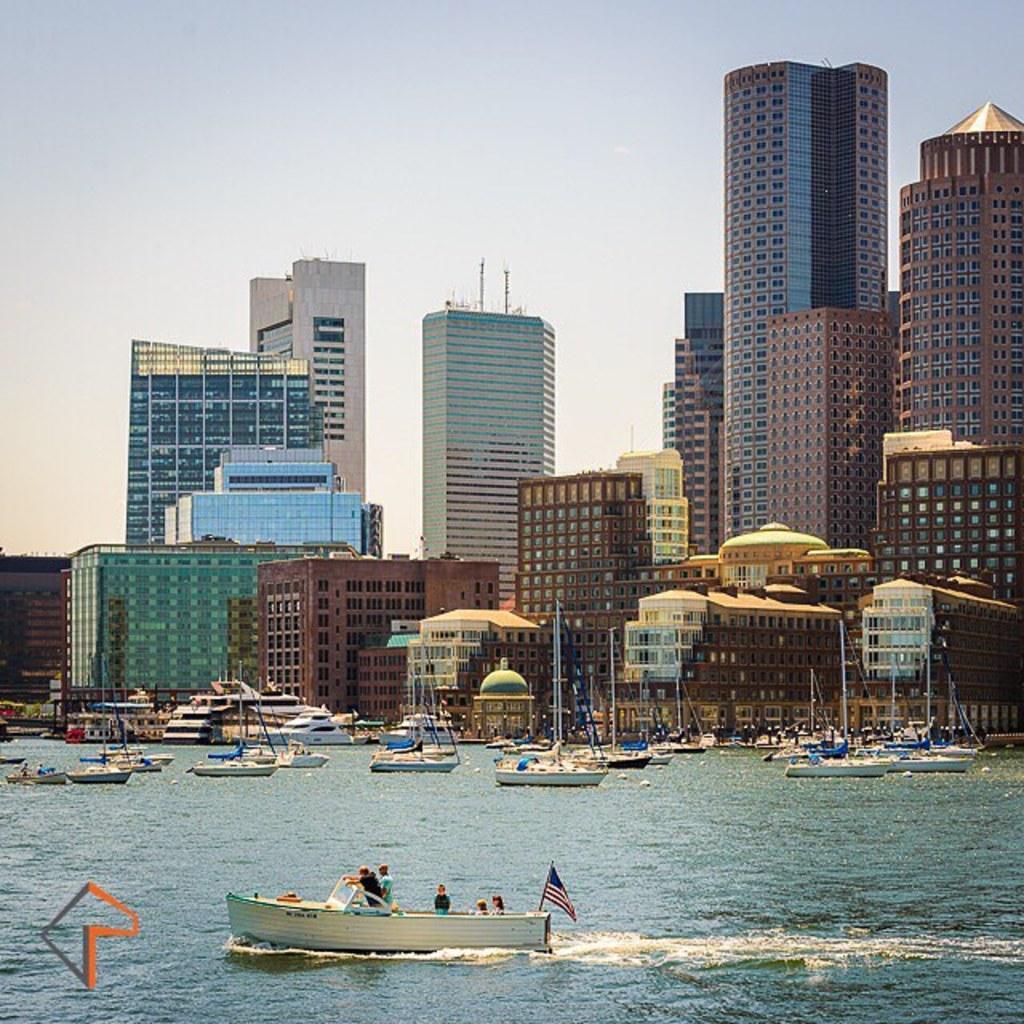Please provide a concise description of this image. In this image, we can see water, there are some boats, we can see some buildings, at the top there is a sky. 